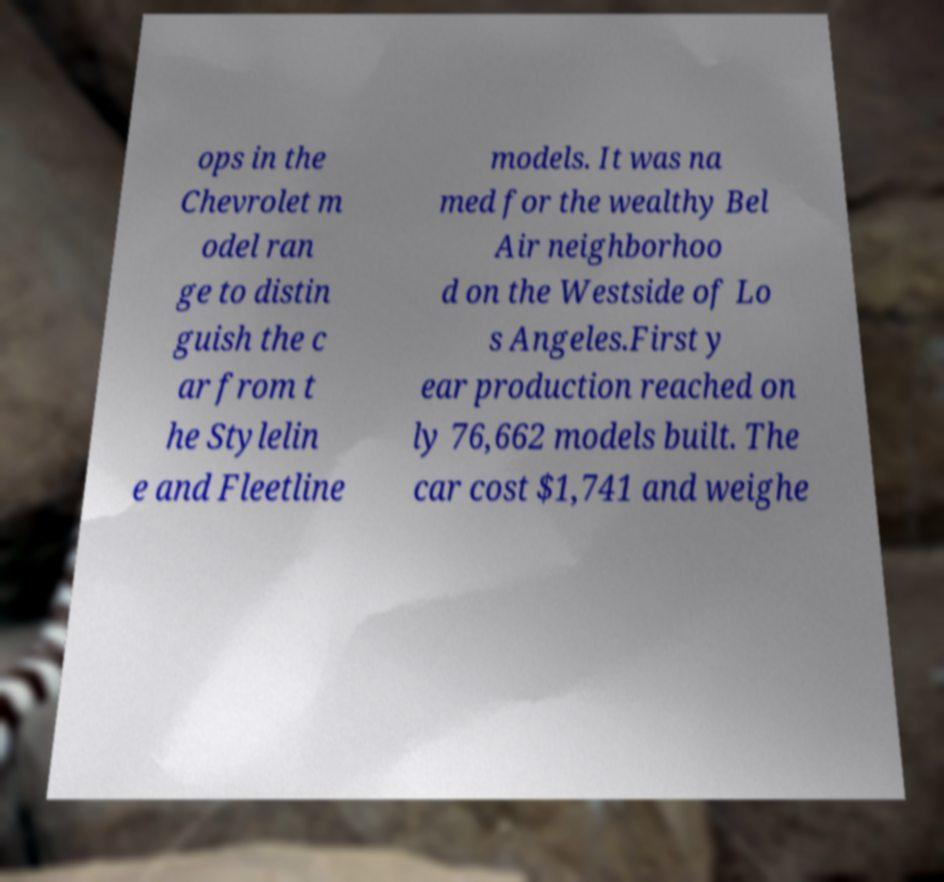There's text embedded in this image that I need extracted. Can you transcribe it verbatim? ops in the Chevrolet m odel ran ge to distin guish the c ar from t he Stylelin e and Fleetline models. It was na med for the wealthy Bel Air neighborhoo d on the Westside of Lo s Angeles.First y ear production reached on ly 76,662 models built. The car cost $1,741 and weighe 